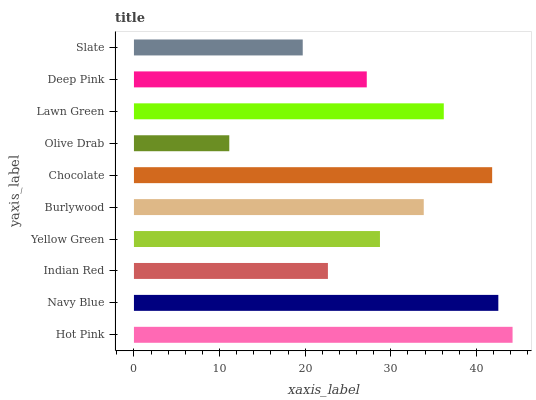Is Olive Drab the minimum?
Answer yes or no. Yes. Is Hot Pink the maximum?
Answer yes or no. Yes. Is Navy Blue the minimum?
Answer yes or no. No. Is Navy Blue the maximum?
Answer yes or no. No. Is Hot Pink greater than Navy Blue?
Answer yes or no. Yes. Is Navy Blue less than Hot Pink?
Answer yes or no. Yes. Is Navy Blue greater than Hot Pink?
Answer yes or no. No. Is Hot Pink less than Navy Blue?
Answer yes or no. No. Is Burlywood the high median?
Answer yes or no. Yes. Is Yellow Green the low median?
Answer yes or no. Yes. Is Indian Red the high median?
Answer yes or no. No. Is Hot Pink the low median?
Answer yes or no. No. 